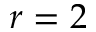<formula> <loc_0><loc_0><loc_500><loc_500>r = 2</formula> 